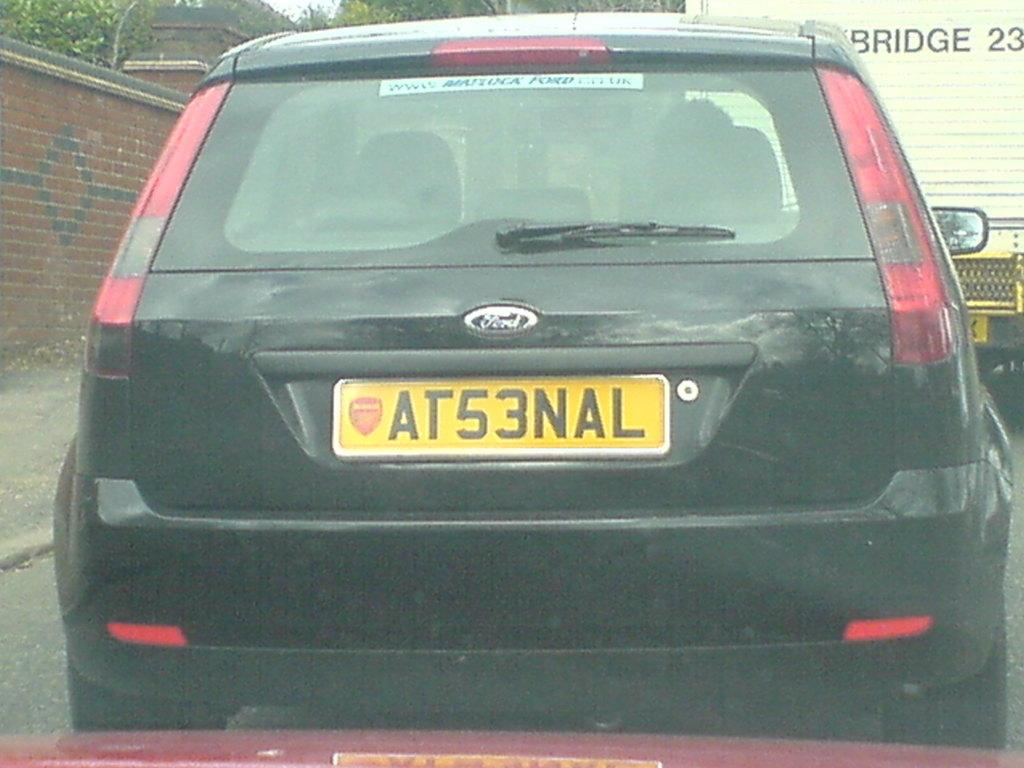<image>
Present a compact description of the photo's key features. A black Ford car behind a truck that says BRIDGE 23 